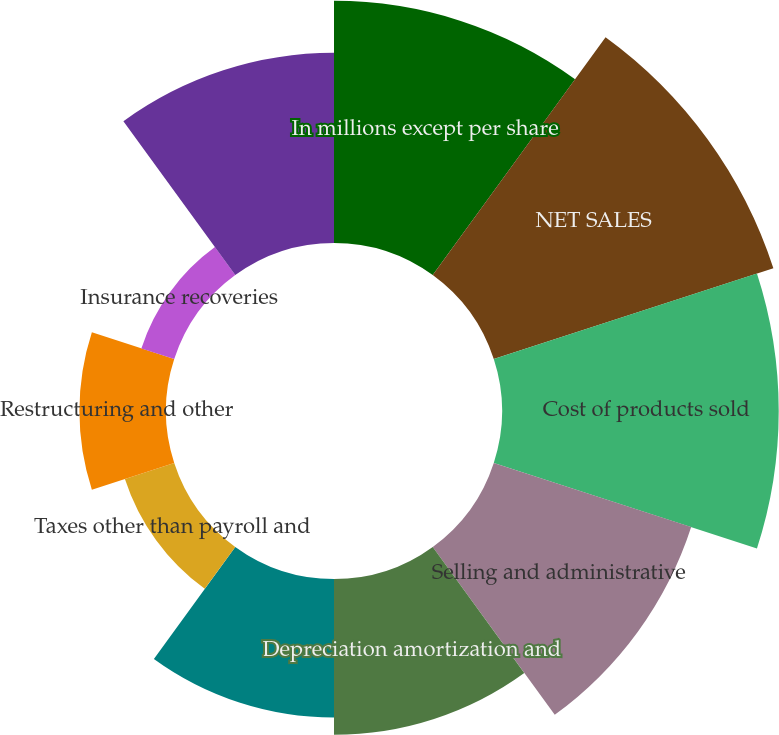<chart> <loc_0><loc_0><loc_500><loc_500><pie_chart><fcel>In millions except per share<fcel>NET SALES<fcel>Cost of products sold<fcel>Selling and administrative<fcel>Depreciation amortization and<fcel>Distribution expenses<fcel>Taxes other than payroll and<fcel>Restructuring and other<fcel>Insurance recoveries<fcel>Net losses on sales and<nl><fcel>14.43%<fcel>17.52%<fcel>16.49%<fcel>12.37%<fcel>9.28%<fcel>8.25%<fcel>3.09%<fcel>5.16%<fcel>2.06%<fcel>11.34%<nl></chart> 